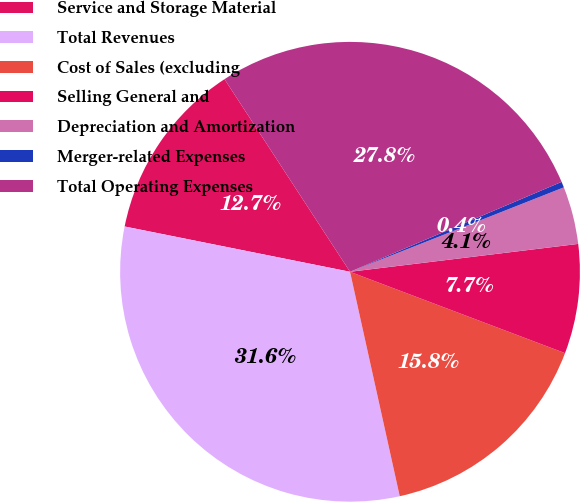Convert chart. <chart><loc_0><loc_0><loc_500><loc_500><pie_chart><fcel>Service and Storage Material<fcel>Total Revenues<fcel>Cost of Sales (excluding<fcel>Selling General and<fcel>Depreciation and Amortization<fcel>Merger-related Expenses<fcel>Total Operating Expenses<nl><fcel>12.65%<fcel>31.62%<fcel>15.77%<fcel>7.69%<fcel>4.05%<fcel>0.41%<fcel>27.79%<nl></chart> 